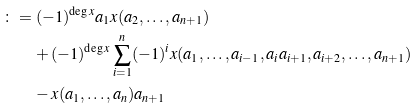<formula> <loc_0><loc_0><loc_500><loc_500>\colon = \, & \, ( - 1 ) ^ { \deg x } a _ { 1 } x ( a _ { 2 } , \dots , a _ { n + 1 } ) \\ & + ( - 1 ) ^ { \deg x } \sum _ { i = 1 } ^ { n } ( - 1 ) ^ { i } x ( a _ { 1 } , \dots , a _ { i - 1 } , a _ { i } a _ { i + 1 } , a _ { i + 2 } , \dots , a _ { n + 1 } ) \\ & - x ( a _ { 1 } , \dots , a _ { n } ) a _ { n + 1 }</formula> 